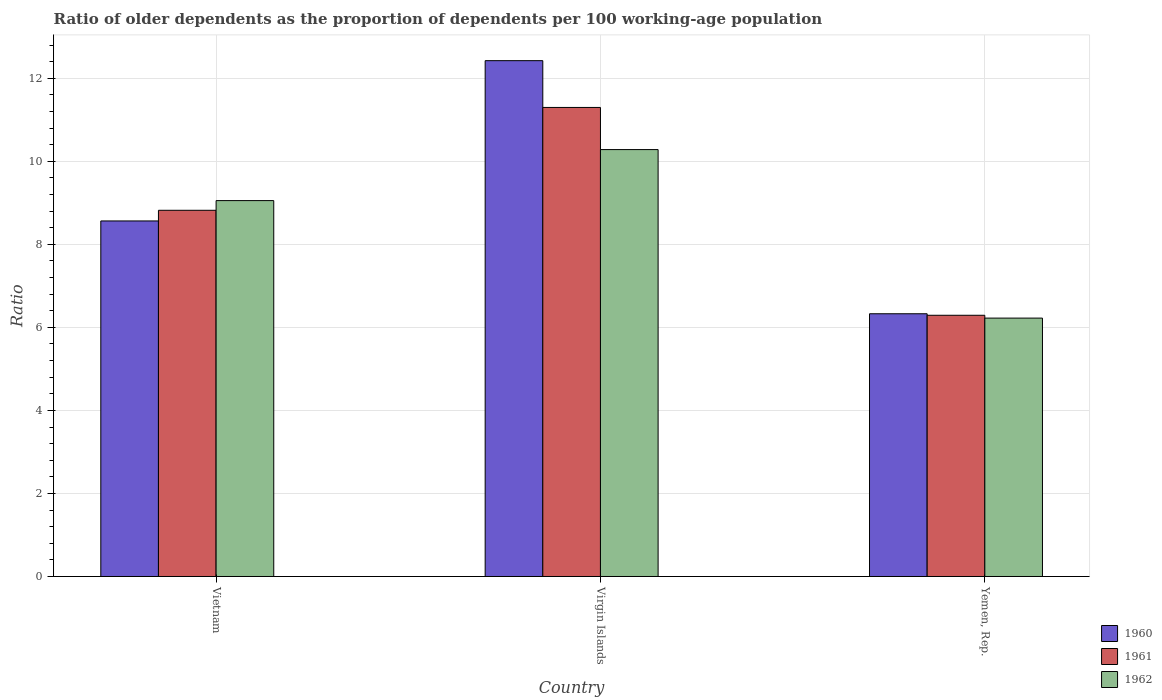How many groups of bars are there?
Provide a succinct answer. 3. How many bars are there on the 3rd tick from the left?
Your answer should be compact. 3. What is the label of the 3rd group of bars from the left?
Provide a succinct answer. Yemen, Rep. In how many cases, is the number of bars for a given country not equal to the number of legend labels?
Give a very brief answer. 0. What is the age dependency ratio(old) in 1960 in Yemen, Rep.?
Offer a terse response. 6.33. Across all countries, what is the maximum age dependency ratio(old) in 1960?
Give a very brief answer. 12.42. Across all countries, what is the minimum age dependency ratio(old) in 1962?
Offer a terse response. 6.22. In which country was the age dependency ratio(old) in 1962 maximum?
Give a very brief answer. Virgin Islands. In which country was the age dependency ratio(old) in 1962 minimum?
Offer a very short reply. Yemen, Rep. What is the total age dependency ratio(old) in 1960 in the graph?
Your answer should be very brief. 27.31. What is the difference between the age dependency ratio(old) in 1962 in Virgin Islands and that in Yemen, Rep.?
Your answer should be very brief. 4.06. What is the difference between the age dependency ratio(old) in 1960 in Virgin Islands and the age dependency ratio(old) in 1961 in Yemen, Rep.?
Keep it short and to the point. 6.13. What is the average age dependency ratio(old) in 1961 per country?
Make the answer very short. 8.8. What is the difference between the age dependency ratio(old) of/in 1962 and age dependency ratio(old) of/in 1960 in Vietnam?
Keep it short and to the point. 0.49. What is the ratio of the age dependency ratio(old) in 1961 in Virgin Islands to that in Yemen, Rep.?
Keep it short and to the point. 1.8. Is the age dependency ratio(old) in 1961 in Virgin Islands less than that in Yemen, Rep.?
Your response must be concise. No. Is the difference between the age dependency ratio(old) in 1962 in Virgin Islands and Yemen, Rep. greater than the difference between the age dependency ratio(old) in 1960 in Virgin Islands and Yemen, Rep.?
Make the answer very short. No. What is the difference between the highest and the second highest age dependency ratio(old) in 1960?
Provide a short and direct response. -3.86. What is the difference between the highest and the lowest age dependency ratio(old) in 1961?
Offer a terse response. 5.01. In how many countries, is the age dependency ratio(old) in 1960 greater than the average age dependency ratio(old) in 1960 taken over all countries?
Your answer should be very brief. 1. What does the 2nd bar from the left in Yemen, Rep. represents?
Provide a short and direct response. 1961. Are all the bars in the graph horizontal?
Your answer should be compact. No. What is the difference between two consecutive major ticks on the Y-axis?
Offer a terse response. 2. Are the values on the major ticks of Y-axis written in scientific E-notation?
Offer a very short reply. No. Does the graph contain any zero values?
Provide a short and direct response. No. Does the graph contain grids?
Ensure brevity in your answer.  Yes. How are the legend labels stacked?
Your response must be concise. Vertical. What is the title of the graph?
Offer a very short reply. Ratio of older dependents as the proportion of dependents per 100 working-age population. Does "1972" appear as one of the legend labels in the graph?
Ensure brevity in your answer.  No. What is the label or title of the X-axis?
Your answer should be very brief. Country. What is the label or title of the Y-axis?
Your answer should be compact. Ratio. What is the Ratio of 1960 in Vietnam?
Offer a very short reply. 8.56. What is the Ratio in 1961 in Vietnam?
Provide a succinct answer. 8.82. What is the Ratio in 1962 in Vietnam?
Your answer should be very brief. 9.05. What is the Ratio in 1960 in Virgin Islands?
Keep it short and to the point. 12.42. What is the Ratio of 1961 in Virgin Islands?
Offer a very short reply. 11.3. What is the Ratio of 1962 in Virgin Islands?
Your response must be concise. 10.28. What is the Ratio in 1960 in Yemen, Rep.?
Provide a succinct answer. 6.33. What is the Ratio of 1961 in Yemen, Rep.?
Offer a very short reply. 6.29. What is the Ratio of 1962 in Yemen, Rep.?
Ensure brevity in your answer.  6.22. Across all countries, what is the maximum Ratio in 1960?
Provide a succinct answer. 12.42. Across all countries, what is the maximum Ratio of 1961?
Your response must be concise. 11.3. Across all countries, what is the maximum Ratio in 1962?
Your answer should be very brief. 10.28. Across all countries, what is the minimum Ratio of 1960?
Offer a very short reply. 6.33. Across all countries, what is the minimum Ratio in 1961?
Offer a terse response. 6.29. Across all countries, what is the minimum Ratio of 1962?
Give a very brief answer. 6.22. What is the total Ratio of 1960 in the graph?
Provide a short and direct response. 27.31. What is the total Ratio in 1961 in the graph?
Give a very brief answer. 26.41. What is the total Ratio of 1962 in the graph?
Provide a succinct answer. 25.56. What is the difference between the Ratio of 1960 in Vietnam and that in Virgin Islands?
Ensure brevity in your answer.  -3.86. What is the difference between the Ratio in 1961 in Vietnam and that in Virgin Islands?
Your response must be concise. -2.48. What is the difference between the Ratio of 1962 in Vietnam and that in Virgin Islands?
Provide a short and direct response. -1.23. What is the difference between the Ratio in 1960 in Vietnam and that in Yemen, Rep.?
Keep it short and to the point. 2.24. What is the difference between the Ratio in 1961 in Vietnam and that in Yemen, Rep.?
Your answer should be very brief. 2.53. What is the difference between the Ratio in 1962 in Vietnam and that in Yemen, Rep.?
Your answer should be very brief. 2.83. What is the difference between the Ratio in 1960 in Virgin Islands and that in Yemen, Rep.?
Make the answer very short. 6.1. What is the difference between the Ratio of 1961 in Virgin Islands and that in Yemen, Rep.?
Offer a terse response. 5.01. What is the difference between the Ratio in 1962 in Virgin Islands and that in Yemen, Rep.?
Make the answer very short. 4.06. What is the difference between the Ratio of 1960 in Vietnam and the Ratio of 1961 in Virgin Islands?
Keep it short and to the point. -2.73. What is the difference between the Ratio in 1960 in Vietnam and the Ratio in 1962 in Virgin Islands?
Offer a terse response. -1.72. What is the difference between the Ratio of 1961 in Vietnam and the Ratio of 1962 in Virgin Islands?
Offer a terse response. -1.46. What is the difference between the Ratio of 1960 in Vietnam and the Ratio of 1961 in Yemen, Rep.?
Provide a short and direct response. 2.27. What is the difference between the Ratio of 1960 in Vietnam and the Ratio of 1962 in Yemen, Rep.?
Offer a terse response. 2.34. What is the difference between the Ratio of 1961 in Vietnam and the Ratio of 1962 in Yemen, Rep.?
Make the answer very short. 2.6. What is the difference between the Ratio in 1960 in Virgin Islands and the Ratio in 1961 in Yemen, Rep.?
Your answer should be very brief. 6.13. What is the difference between the Ratio in 1960 in Virgin Islands and the Ratio in 1962 in Yemen, Rep.?
Make the answer very short. 6.2. What is the difference between the Ratio in 1961 in Virgin Islands and the Ratio in 1962 in Yemen, Rep.?
Offer a terse response. 5.07. What is the average Ratio in 1960 per country?
Ensure brevity in your answer.  9.1. What is the average Ratio in 1961 per country?
Your answer should be compact. 8.8. What is the average Ratio in 1962 per country?
Your answer should be very brief. 8.52. What is the difference between the Ratio of 1960 and Ratio of 1961 in Vietnam?
Make the answer very short. -0.26. What is the difference between the Ratio of 1960 and Ratio of 1962 in Vietnam?
Keep it short and to the point. -0.49. What is the difference between the Ratio in 1961 and Ratio in 1962 in Vietnam?
Give a very brief answer. -0.23. What is the difference between the Ratio in 1960 and Ratio in 1961 in Virgin Islands?
Offer a terse response. 1.13. What is the difference between the Ratio in 1960 and Ratio in 1962 in Virgin Islands?
Your answer should be compact. 2.14. What is the difference between the Ratio in 1961 and Ratio in 1962 in Virgin Islands?
Your response must be concise. 1.01. What is the difference between the Ratio of 1960 and Ratio of 1961 in Yemen, Rep.?
Your answer should be very brief. 0.04. What is the difference between the Ratio of 1960 and Ratio of 1962 in Yemen, Rep.?
Your response must be concise. 0.1. What is the difference between the Ratio of 1961 and Ratio of 1962 in Yemen, Rep.?
Give a very brief answer. 0.07. What is the ratio of the Ratio of 1960 in Vietnam to that in Virgin Islands?
Ensure brevity in your answer.  0.69. What is the ratio of the Ratio in 1961 in Vietnam to that in Virgin Islands?
Ensure brevity in your answer.  0.78. What is the ratio of the Ratio of 1962 in Vietnam to that in Virgin Islands?
Your answer should be compact. 0.88. What is the ratio of the Ratio of 1960 in Vietnam to that in Yemen, Rep.?
Offer a very short reply. 1.35. What is the ratio of the Ratio of 1961 in Vietnam to that in Yemen, Rep.?
Your answer should be very brief. 1.4. What is the ratio of the Ratio in 1962 in Vietnam to that in Yemen, Rep.?
Offer a very short reply. 1.45. What is the ratio of the Ratio in 1960 in Virgin Islands to that in Yemen, Rep.?
Your answer should be compact. 1.96. What is the ratio of the Ratio of 1961 in Virgin Islands to that in Yemen, Rep.?
Offer a very short reply. 1.8. What is the ratio of the Ratio of 1962 in Virgin Islands to that in Yemen, Rep.?
Give a very brief answer. 1.65. What is the difference between the highest and the second highest Ratio in 1960?
Give a very brief answer. 3.86. What is the difference between the highest and the second highest Ratio in 1961?
Provide a short and direct response. 2.48. What is the difference between the highest and the second highest Ratio in 1962?
Your response must be concise. 1.23. What is the difference between the highest and the lowest Ratio in 1960?
Keep it short and to the point. 6.1. What is the difference between the highest and the lowest Ratio in 1961?
Your response must be concise. 5.01. What is the difference between the highest and the lowest Ratio of 1962?
Make the answer very short. 4.06. 